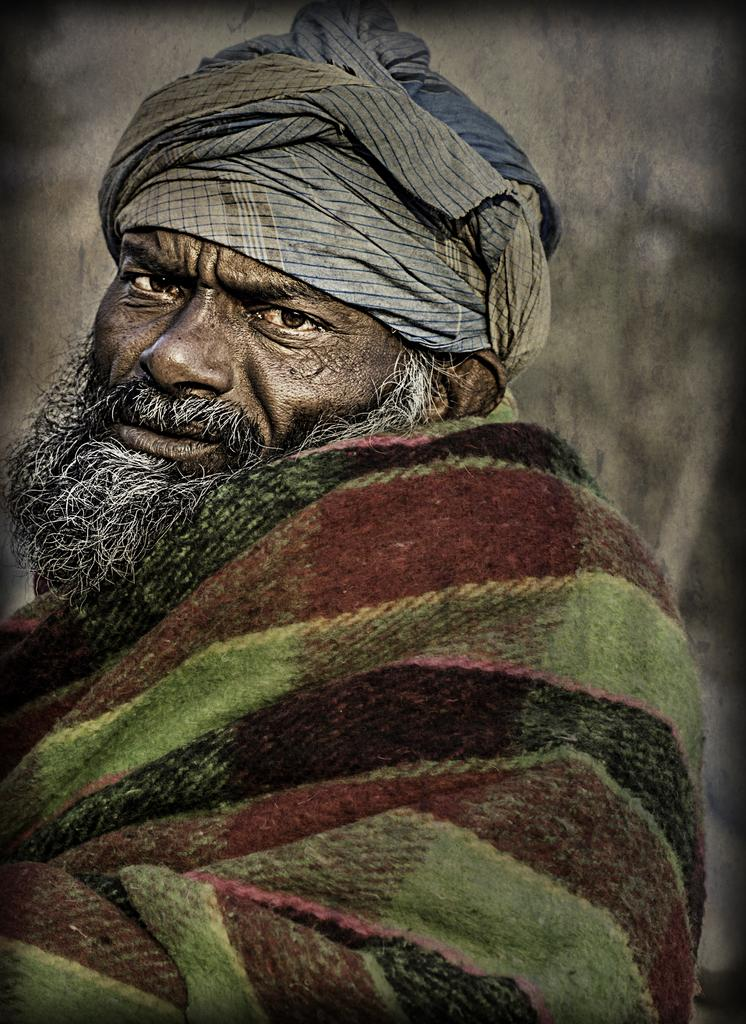Who is the main subject in the picture? There is an old man in the picture. What facial hair does the old man have? The old man has a mustache and beard. What color is the old man's mustache and beard? The mustache and beard are white. What clothing items is the old man wearing? The old man is wearing a cloth and a turban on his head. How many ghosts are visible in the image? There are no ghosts present in the image. What type of finger is the old man wearing on his hand? The old man is not wearing a finger; he has his own fingers. 